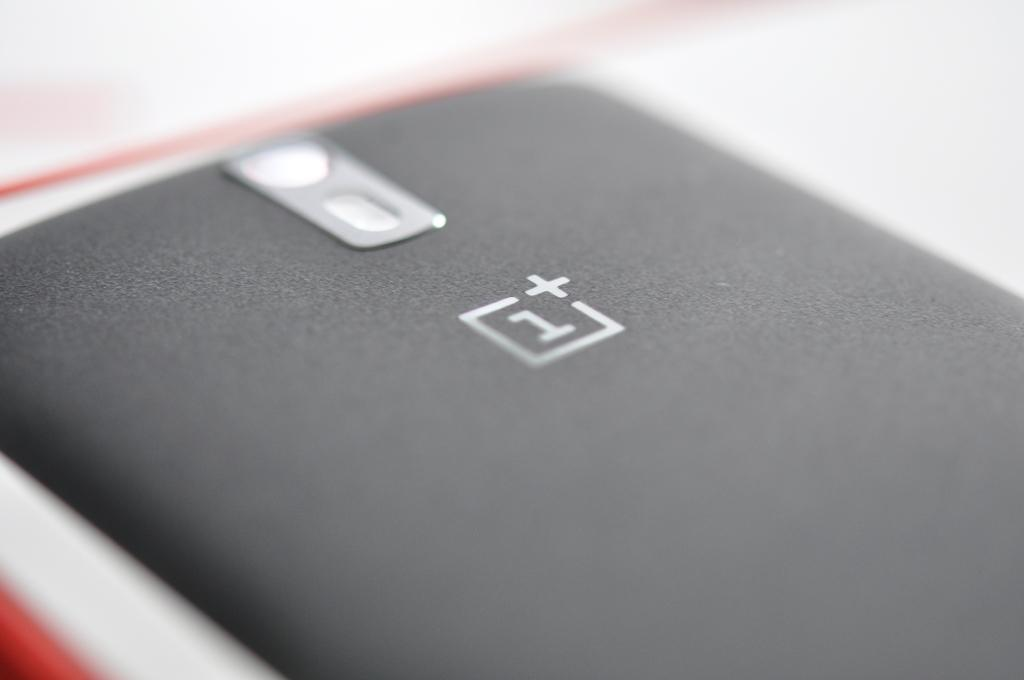<image>
Create a compact narrative representing the image presented. The back of a phone with a logo for 1 Plus under the camera eye. 